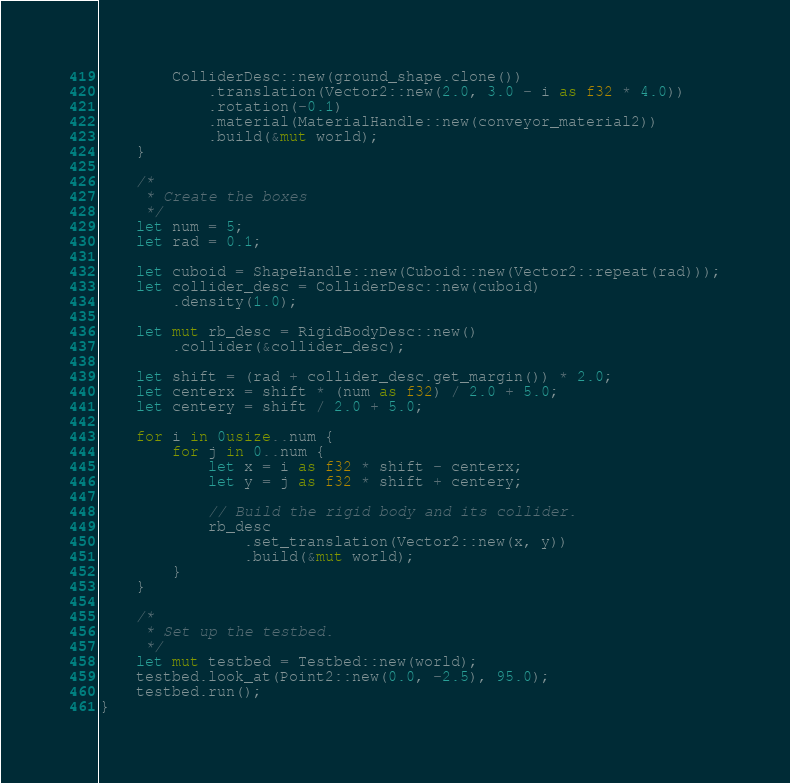<code> <loc_0><loc_0><loc_500><loc_500><_Rust_>
        ColliderDesc::new(ground_shape.clone())
            .translation(Vector2::new(2.0, 3.0 - i as f32 * 4.0))
            .rotation(-0.1)
            .material(MaterialHandle::new(conveyor_material2))
            .build(&mut world);
    }

    /*
     * Create the boxes
     */
    let num = 5;
    let rad = 0.1;

    let cuboid = ShapeHandle::new(Cuboid::new(Vector2::repeat(rad)));
    let collider_desc = ColliderDesc::new(cuboid)
        .density(1.0);

    let mut rb_desc = RigidBodyDesc::new()
        .collider(&collider_desc);

    let shift = (rad + collider_desc.get_margin()) * 2.0;
    let centerx = shift * (num as f32) / 2.0 + 5.0;
    let centery = shift / 2.0 + 5.0;

    for i in 0usize..num {
        for j in 0..num {
            let x = i as f32 * shift - centerx;
            let y = j as f32 * shift + centery;

            // Build the rigid body and its collider.
            rb_desc
                .set_translation(Vector2::new(x, y))
                .build(&mut world);
        }
    }

    /*
     * Set up the testbed.
     */
    let mut testbed = Testbed::new(world);
    testbed.look_at(Point2::new(0.0, -2.5), 95.0);
    testbed.run();
}
</code> 